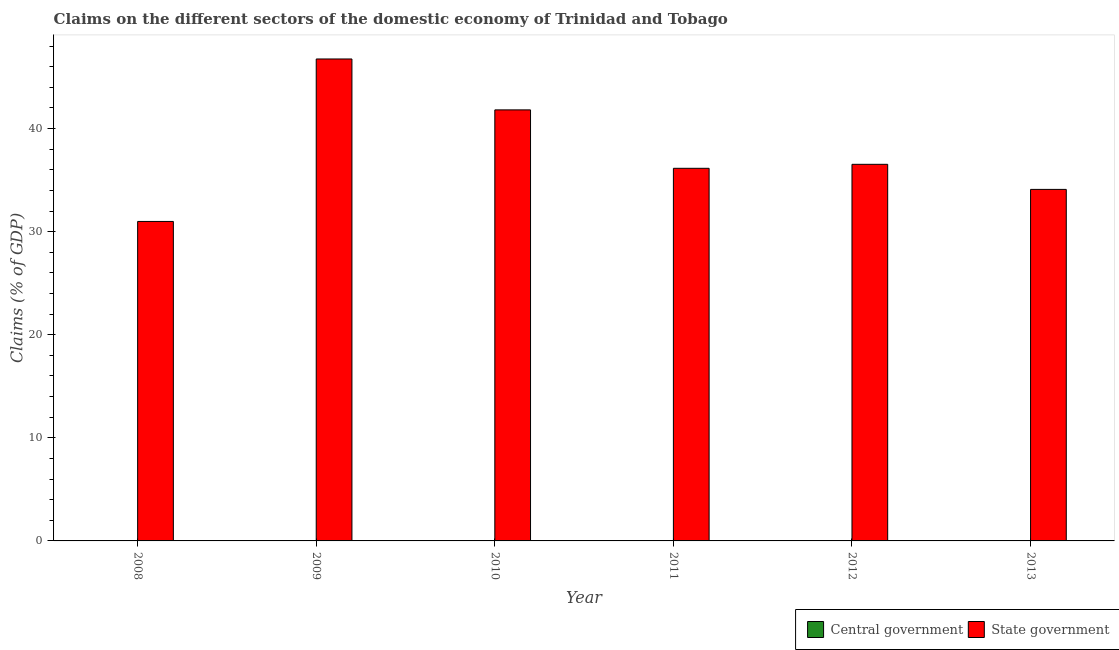Are the number of bars on each tick of the X-axis equal?
Your answer should be very brief. Yes. How many bars are there on the 1st tick from the right?
Ensure brevity in your answer.  1. What is the claims on central government in 2012?
Keep it short and to the point. 0. Across all years, what is the maximum claims on state government?
Ensure brevity in your answer.  46.75. Across all years, what is the minimum claims on state government?
Make the answer very short. 30.99. In which year was the claims on state government maximum?
Your answer should be compact. 2009. What is the total claims on state government in the graph?
Your response must be concise. 226.3. What is the difference between the claims on state government in 2010 and that in 2011?
Your answer should be compact. 5.67. What is the difference between the claims on central government in 2009 and the claims on state government in 2008?
Ensure brevity in your answer.  0. What is the average claims on central government per year?
Your response must be concise. 0. In the year 2009, what is the difference between the claims on state government and claims on central government?
Provide a succinct answer. 0. In how many years, is the claims on state government greater than 28 %?
Provide a short and direct response. 6. What is the ratio of the claims on state government in 2012 to that in 2013?
Ensure brevity in your answer.  1.07. Is the claims on state government in 2008 less than that in 2010?
Provide a succinct answer. Yes. Is the difference between the claims on state government in 2009 and 2013 greater than the difference between the claims on central government in 2009 and 2013?
Your answer should be very brief. No. What is the difference between the highest and the second highest claims on state government?
Provide a succinct answer. 4.94. In how many years, is the claims on central government greater than the average claims on central government taken over all years?
Provide a succinct answer. 0. Are all the bars in the graph horizontal?
Provide a succinct answer. No. How many years are there in the graph?
Your answer should be very brief. 6. Are the values on the major ticks of Y-axis written in scientific E-notation?
Keep it short and to the point. No. Does the graph contain grids?
Your response must be concise. No. How many legend labels are there?
Offer a very short reply. 2. How are the legend labels stacked?
Offer a very short reply. Horizontal. What is the title of the graph?
Provide a succinct answer. Claims on the different sectors of the domestic economy of Trinidad and Tobago. Does "Age 65(female)" appear as one of the legend labels in the graph?
Give a very brief answer. No. What is the label or title of the X-axis?
Your answer should be compact. Year. What is the label or title of the Y-axis?
Keep it short and to the point. Claims (% of GDP). What is the Claims (% of GDP) in Central government in 2008?
Your answer should be compact. 0. What is the Claims (% of GDP) of State government in 2008?
Keep it short and to the point. 30.99. What is the Claims (% of GDP) in Central government in 2009?
Ensure brevity in your answer.  0. What is the Claims (% of GDP) in State government in 2009?
Keep it short and to the point. 46.75. What is the Claims (% of GDP) of Central government in 2010?
Offer a terse response. 0. What is the Claims (% of GDP) of State government in 2010?
Give a very brief answer. 41.81. What is the Claims (% of GDP) of Central government in 2011?
Your answer should be very brief. 0. What is the Claims (% of GDP) of State government in 2011?
Your response must be concise. 36.14. What is the Claims (% of GDP) in Central government in 2012?
Your answer should be very brief. 0. What is the Claims (% of GDP) in State government in 2012?
Give a very brief answer. 36.53. What is the Claims (% of GDP) in Central government in 2013?
Provide a short and direct response. 0. What is the Claims (% of GDP) in State government in 2013?
Make the answer very short. 34.09. Across all years, what is the maximum Claims (% of GDP) of State government?
Ensure brevity in your answer.  46.75. Across all years, what is the minimum Claims (% of GDP) in State government?
Make the answer very short. 30.99. What is the total Claims (% of GDP) of State government in the graph?
Provide a short and direct response. 226.3. What is the difference between the Claims (% of GDP) of State government in 2008 and that in 2009?
Your answer should be very brief. -15.76. What is the difference between the Claims (% of GDP) of State government in 2008 and that in 2010?
Your response must be concise. -10.82. What is the difference between the Claims (% of GDP) in State government in 2008 and that in 2011?
Offer a very short reply. -5.15. What is the difference between the Claims (% of GDP) in State government in 2008 and that in 2012?
Your answer should be compact. -5.54. What is the difference between the Claims (% of GDP) of State government in 2008 and that in 2013?
Your answer should be compact. -3.11. What is the difference between the Claims (% of GDP) in State government in 2009 and that in 2010?
Give a very brief answer. 4.94. What is the difference between the Claims (% of GDP) in State government in 2009 and that in 2011?
Your response must be concise. 10.6. What is the difference between the Claims (% of GDP) of State government in 2009 and that in 2012?
Your answer should be very brief. 10.22. What is the difference between the Claims (% of GDP) of State government in 2009 and that in 2013?
Your answer should be very brief. 12.65. What is the difference between the Claims (% of GDP) in State government in 2010 and that in 2011?
Provide a short and direct response. 5.67. What is the difference between the Claims (% of GDP) in State government in 2010 and that in 2012?
Provide a succinct answer. 5.28. What is the difference between the Claims (% of GDP) of State government in 2010 and that in 2013?
Your response must be concise. 7.71. What is the difference between the Claims (% of GDP) in State government in 2011 and that in 2012?
Provide a succinct answer. -0.39. What is the difference between the Claims (% of GDP) in State government in 2011 and that in 2013?
Provide a short and direct response. 2.05. What is the difference between the Claims (% of GDP) in State government in 2012 and that in 2013?
Offer a terse response. 2.43. What is the average Claims (% of GDP) of State government per year?
Your answer should be compact. 37.72. What is the ratio of the Claims (% of GDP) of State government in 2008 to that in 2009?
Your answer should be very brief. 0.66. What is the ratio of the Claims (% of GDP) in State government in 2008 to that in 2010?
Your answer should be very brief. 0.74. What is the ratio of the Claims (% of GDP) in State government in 2008 to that in 2011?
Your answer should be very brief. 0.86. What is the ratio of the Claims (% of GDP) in State government in 2008 to that in 2012?
Give a very brief answer. 0.85. What is the ratio of the Claims (% of GDP) of State government in 2008 to that in 2013?
Keep it short and to the point. 0.91. What is the ratio of the Claims (% of GDP) of State government in 2009 to that in 2010?
Give a very brief answer. 1.12. What is the ratio of the Claims (% of GDP) of State government in 2009 to that in 2011?
Keep it short and to the point. 1.29. What is the ratio of the Claims (% of GDP) in State government in 2009 to that in 2012?
Make the answer very short. 1.28. What is the ratio of the Claims (% of GDP) in State government in 2009 to that in 2013?
Keep it short and to the point. 1.37. What is the ratio of the Claims (% of GDP) in State government in 2010 to that in 2011?
Provide a short and direct response. 1.16. What is the ratio of the Claims (% of GDP) of State government in 2010 to that in 2012?
Make the answer very short. 1.14. What is the ratio of the Claims (% of GDP) in State government in 2010 to that in 2013?
Give a very brief answer. 1.23. What is the ratio of the Claims (% of GDP) of State government in 2011 to that in 2012?
Provide a succinct answer. 0.99. What is the ratio of the Claims (% of GDP) of State government in 2011 to that in 2013?
Give a very brief answer. 1.06. What is the ratio of the Claims (% of GDP) in State government in 2012 to that in 2013?
Ensure brevity in your answer.  1.07. What is the difference between the highest and the second highest Claims (% of GDP) of State government?
Your answer should be compact. 4.94. What is the difference between the highest and the lowest Claims (% of GDP) of State government?
Keep it short and to the point. 15.76. 